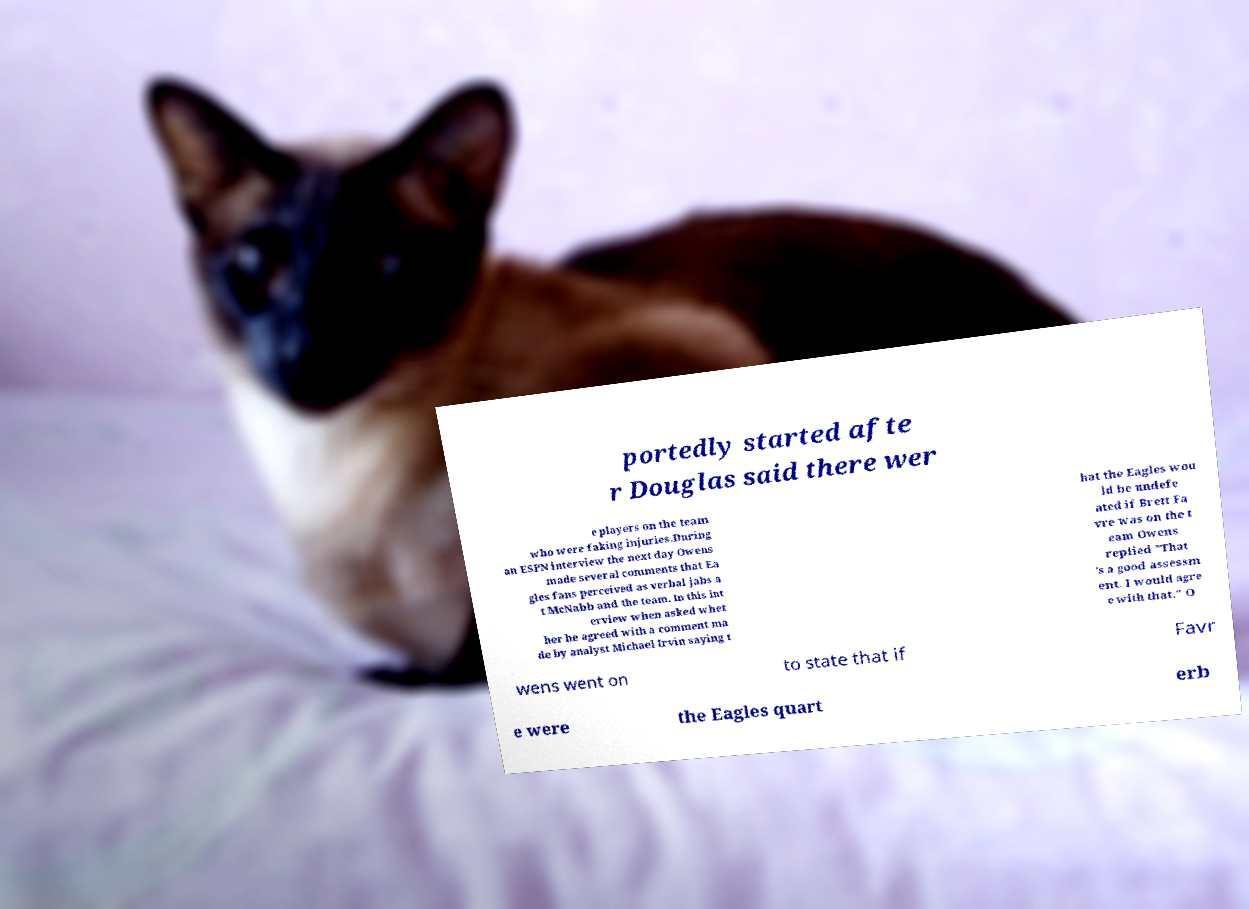There's text embedded in this image that I need extracted. Can you transcribe it verbatim? portedly started afte r Douglas said there wer e players on the team who were faking injuries.During an ESPN interview the next day Owens made several comments that Ea gles fans perceived as verbal jabs a t McNabb and the team. In this int erview when asked whet her he agreed with a comment ma de by analyst Michael Irvin saying t hat the Eagles wou ld be undefe ated if Brett Fa vre was on the t eam Owens replied "That 's a good assessm ent. I would agre e with that." O wens went on to state that if Favr e were the Eagles quart erb 